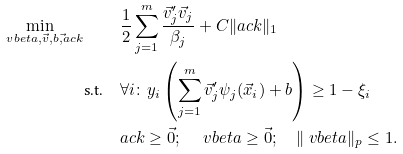<formula> <loc_0><loc_0><loc_500><loc_500>\min _ { \ v b e t a , \vec { v } , b , \vec { \sl } a c k } \quad & \frac { 1 } { 2 } \sum _ { j = 1 } ^ { m } \frac { \vec { v } _ { j } ^ { \prime } \vec { v } _ { j } } { \beta _ { j } } + C \| \sl a c k \| _ { 1 } \\ \text {s.t.} \quad & \forall i \colon y _ { i } \left ( \sum _ { j = 1 } ^ { m } \vec { v } _ { j } ^ { \prime } \psi _ { j } ( \vec { x } _ { i } ) + b \right ) \geq 1 - \xi _ { i } \\ & \sl a c k \geq \vec { 0 } ; \quad \ v b e t a \geq \vec { 0 } ; \quad \| \ v b e t a \| _ { p } \leq 1 .</formula> 